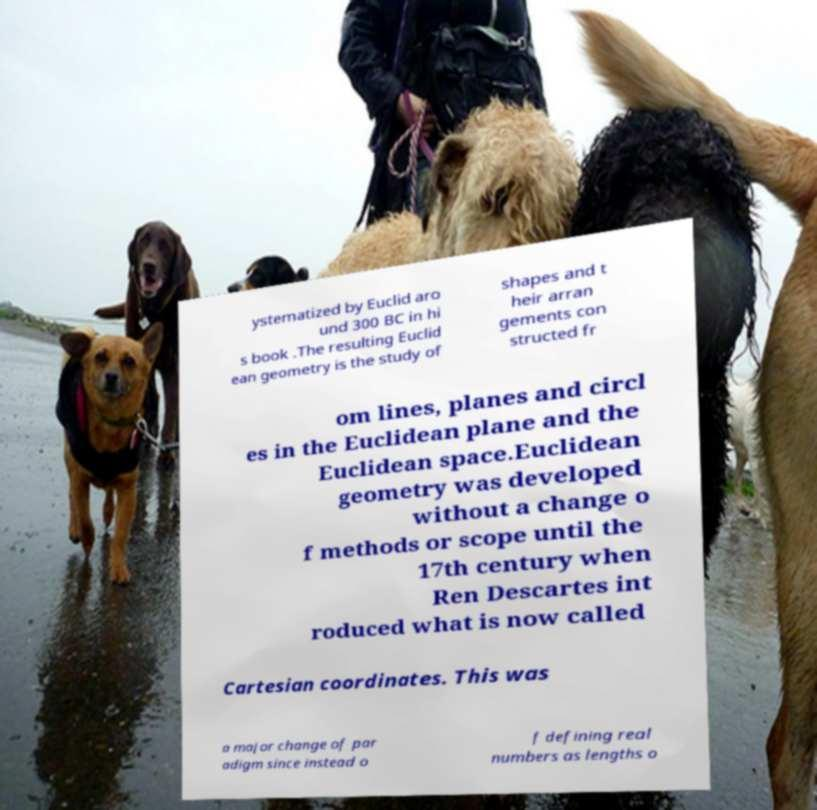Could you assist in decoding the text presented in this image and type it out clearly? ystematized by Euclid aro und 300 BC in hi s book .The resulting Euclid ean geometry is the study of shapes and t heir arran gements con structed fr om lines, planes and circl es in the Euclidean plane and the Euclidean space.Euclidean geometry was developed without a change o f methods or scope until the 17th century when Ren Descartes int roduced what is now called Cartesian coordinates. This was a major change of par adigm since instead o f defining real numbers as lengths o 